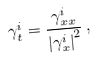Convert formula to latex. <formula><loc_0><loc_0><loc_500><loc_500>\gamma ^ { i } _ { t } = \frac { \gamma _ { x x } ^ { i } } { { | { \gamma _ { x } ^ { i } } | } ^ { 2 } } \, ,</formula> 